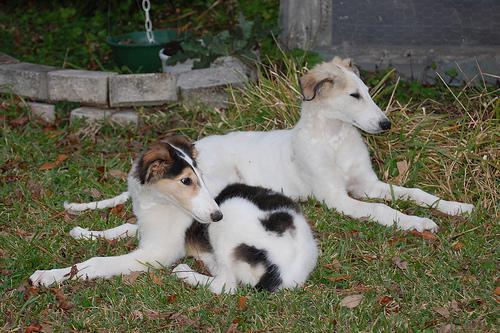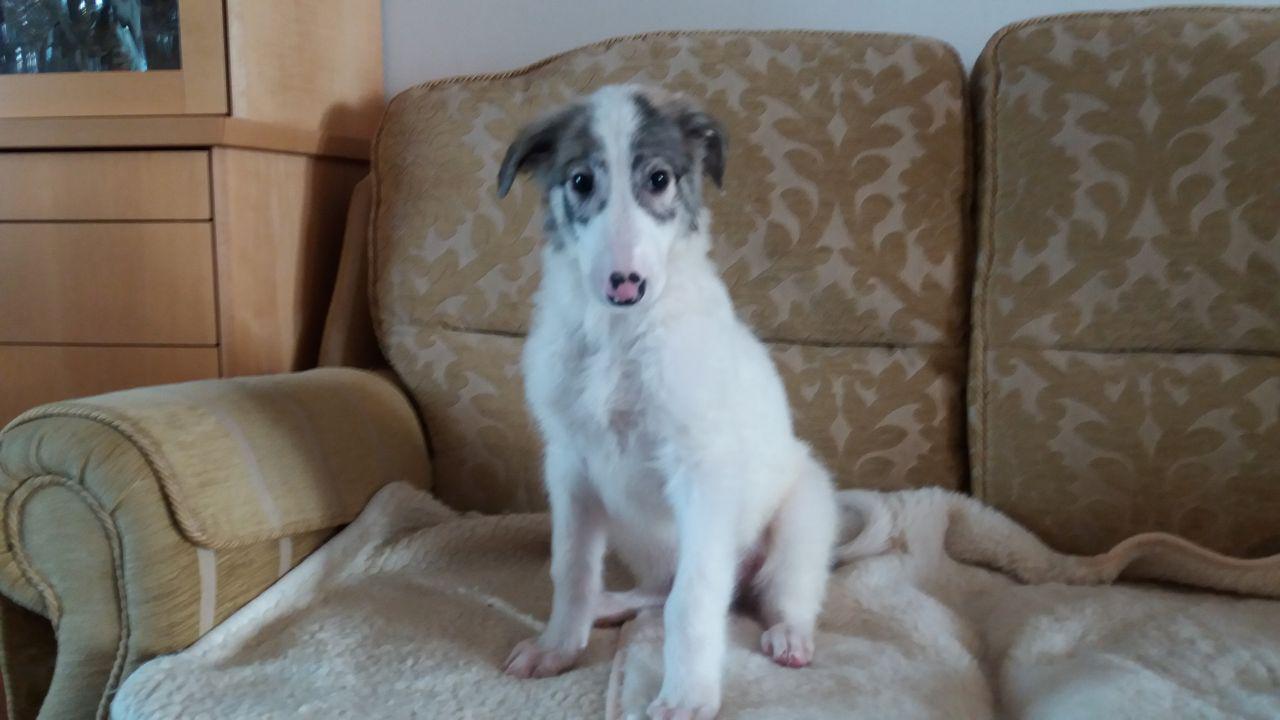The first image is the image on the left, the second image is the image on the right. Given the left and right images, does the statement "An image shows exactly two pet hounds on grass." hold true? Answer yes or no. Yes. The first image is the image on the left, the second image is the image on the right. For the images displayed, is the sentence "One image shows a single dog standing in grass." factually correct? Answer yes or no. No. 